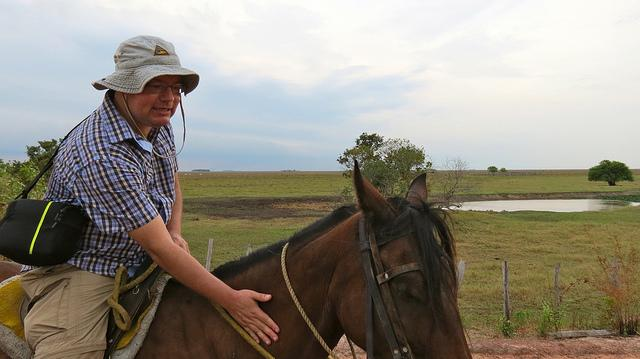What is the man trying to do to the horse?

Choices:
A) punish it
B) milk it
C) calm it
D) feed it calm it 